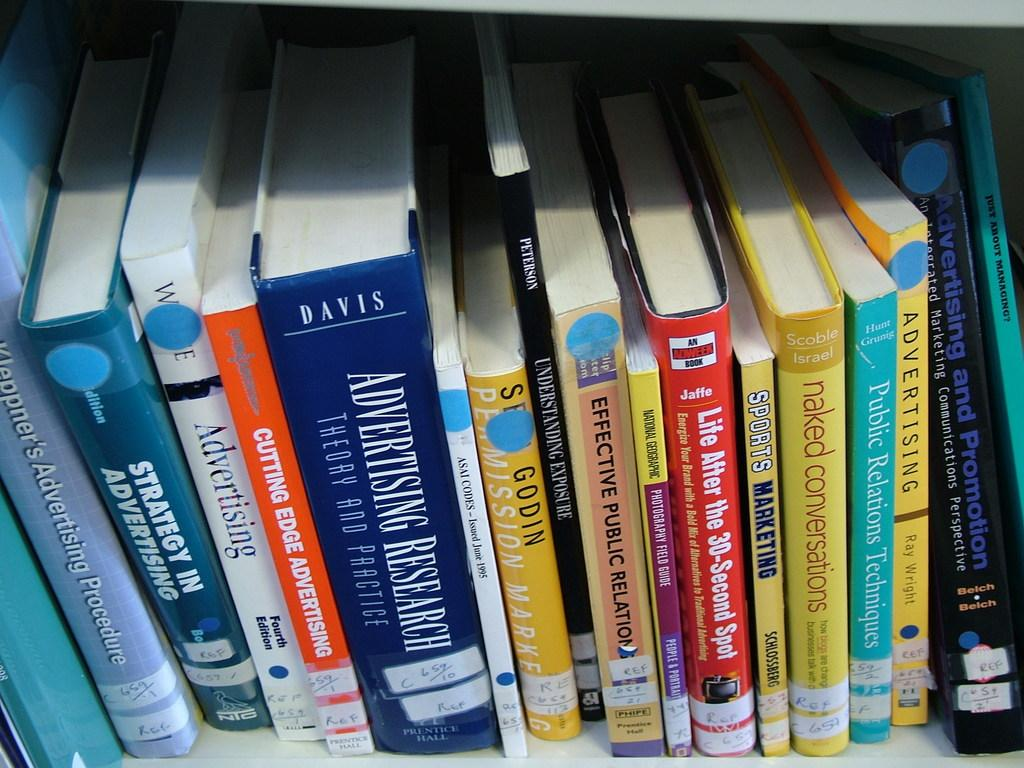<image>
Present a compact description of the photo's key features. The largest book displayed on this shelf is about Advertising. 